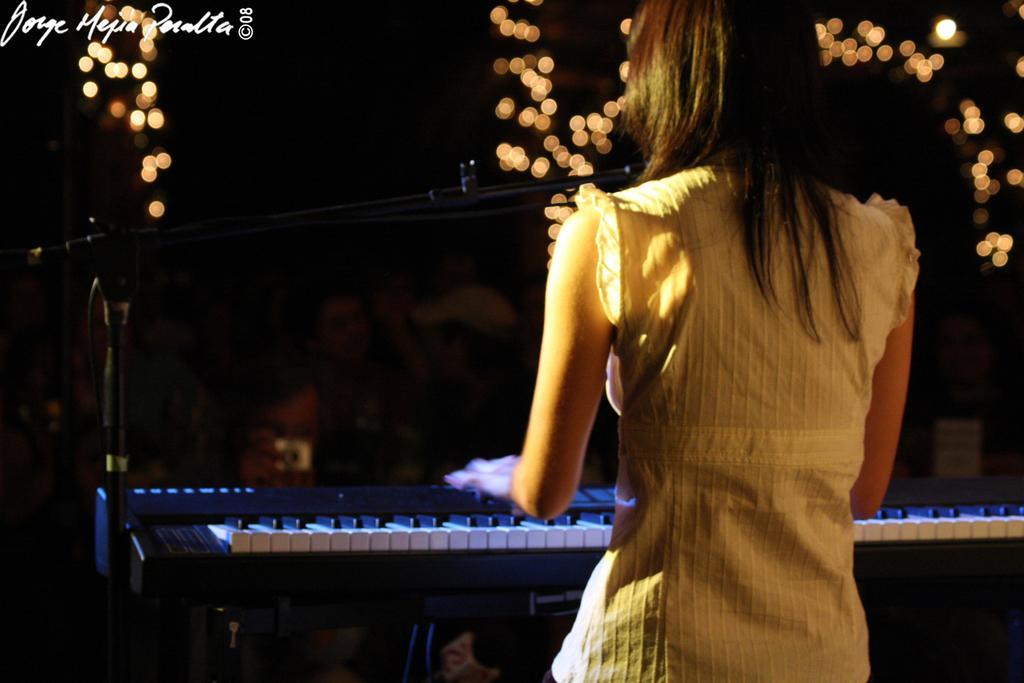In one or two sentences, can you explain what this image depicts? In this picture there is a girl who is standing at the right side of the image and there is a mic in front of her and there is a piano which is placed in front of her, she is playing the piano and there are spot lights above the area of the image. 